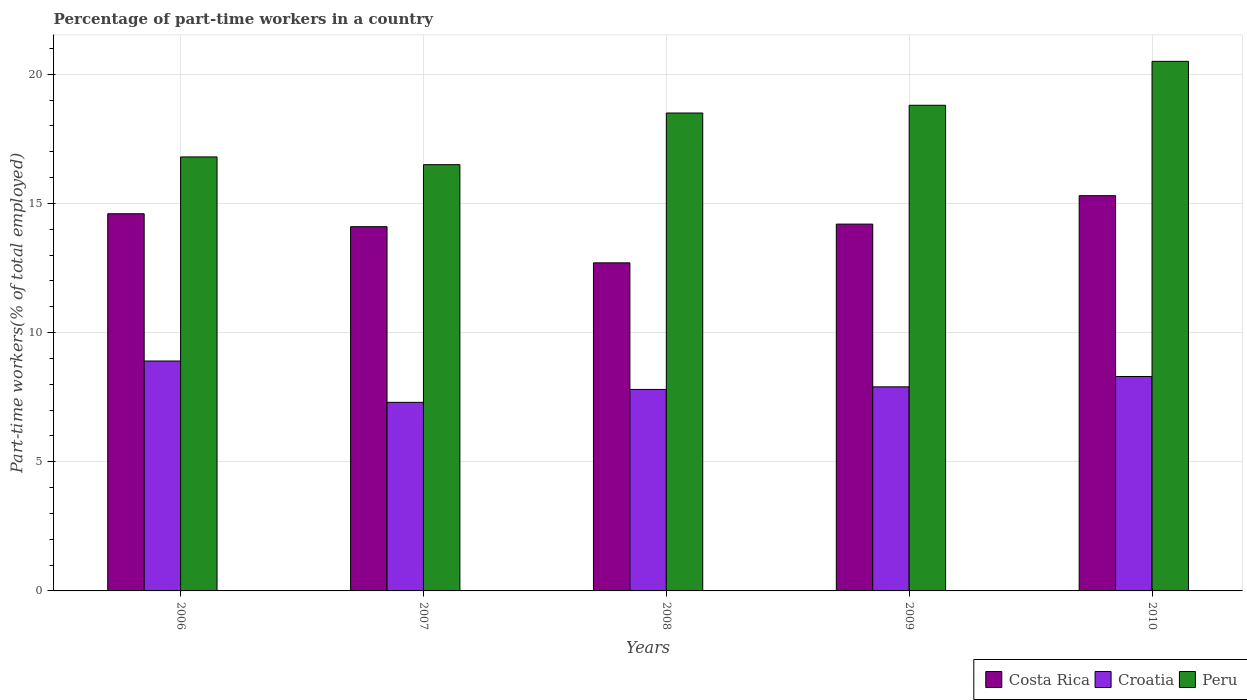How many different coloured bars are there?
Make the answer very short. 3. Are the number of bars per tick equal to the number of legend labels?
Provide a succinct answer. Yes. What is the percentage of part-time workers in Croatia in 2007?
Keep it short and to the point. 7.3. Across all years, what is the maximum percentage of part-time workers in Peru?
Keep it short and to the point. 20.5. Across all years, what is the minimum percentage of part-time workers in Peru?
Keep it short and to the point. 16.5. In which year was the percentage of part-time workers in Peru maximum?
Your answer should be very brief. 2010. In which year was the percentage of part-time workers in Croatia minimum?
Your response must be concise. 2007. What is the total percentage of part-time workers in Costa Rica in the graph?
Your answer should be compact. 70.9. What is the difference between the percentage of part-time workers in Costa Rica in 2008 and that in 2010?
Offer a very short reply. -2.6. What is the difference between the percentage of part-time workers in Costa Rica in 2010 and the percentage of part-time workers in Croatia in 2006?
Offer a terse response. 6.4. What is the average percentage of part-time workers in Croatia per year?
Your response must be concise. 8.04. In the year 2008, what is the difference between the percentage of part-time workers in Croatia and percentage of part-time workers in Costa Rica?
Your answer should be very brief. -4.9. In how many years, is the percentage of part-time workers in Croatia greater than 8 %?
Provide a short and direct response. 2. What is the ratio of the percentage of part-time workers in Croatia in 2007 to that in 2009?
Offer a very short reply. 0.92. Is the difference between the percentage of part-time workers in Croatia in 2007 and 2009 greater than the difference between the percentage of part-time workers in Costa Rica in 2007 and 2009?
Your answer should be very brief. No. What is the difference between the highest and the second highest percentage of part-time workers in Croatia?
Ensure brevity in your answer.  0.6. What is the difference between the highest and the lowest percentage of part-time workers in Costa Rica?
Make the answer very short. 2.6. What does the 3rd bar from the left in 2008 represents?
Ensure brevity in your answer.  Peru. What does the 1st bar from the right in 2006 represents?
Provide a short and direct response. Peru. Is it the case that in every year, the sum of the percentage of part-time workers in Costa Rica and percentage of part-time workers in Croatia is greater than the percentage of part-time workers in Peru?
Provide a succinct answer. Yes. What is the difference between two consecutive major ticks on the Y-axis?
Make the answer very short. 5. Does the graph contain any zero values?
Your answer should be compact. No. How many legend labels are there?
Give a very brief answer. 3. How are the legend labels stacked?
Ensure brevity in your answer.  Horizontal. What is the title of the graph?
Your answer should be compact. Percentage of part-time workers in a country. What is the label or title of the X-axis?
Your response must be concise. Years. What is the label or title of the Y-axis?
Offer a very short reply. Part-time workers(% of total employed). What is the Part-time workers(% of total employed) of Costa Rica in 2006?
Offer a terse response. 14.6. What is the Part-time workers(% of total employed) in Croatia in 2006?
Your answer should be very brief. 8.9. What is the Part-time workers(% of total employed) in Peru in 2006?
Your response must be concise. 16.8. What is the Part-time workers(% of total employed) in Costa Rica in 2007?
Your answer should be very brief. 14.1. What is the Part-time workers(% of total employed) of Croatia in 2007?
Keep it short and to the point. 7.3. What is the Part-time workers(% of total employed) in Costa Rica in 2008?
Offer a very short reply. 12.7. What is the Part-time workers(% of total employed) in Croatia in 2008?
Offer a very short reply. 7.8. What is the Part-time workers(% of total employed) in Costa Rica in 2009?
Your response must be concise. 14.2. What is the Part-time workers(% of total employed) in Croatia in 2009?
Offer a very short reply. 7.9. What is the Part-time workers(% of total employed) in Peru in 2009?
Make the answer very short. 18.8. What is the Part-time workers(% of total employed) of Costa Rica in 2010?
Your response must be concise. 15.3. What is the Part-time workers(% of total employed) of Croatia in 2010?
Your answer should be very brief. 8.3. Across all years, what is the maximum Part-time workers(% of total employed) in Costa Rica?
Make the answer very short. 15.3. Across all years, what is the maximum Part-time workers(% of total employed) of Croatia?
Make the answer very short. 8.9. Across all years, what is the maximum Part-time workers(% of total employed) of Peru?
Give a very brief answer. 20.5. Across all years, what is the minimum Part-time workers(% of total employed) in Costa Rica?
Ensure brevity in your answer.  12.7. Across all years, what is the minimum Part-time workers(% of total employed) in Croatia?
Give a very brief answer. 7.3. What is the total Part-time workers(% of total employed) of Costa Rica in the graph?
Keep it short and to the point. 70.9. What is the total Part-time workers(% of total employed) of Croatia in the graph?
Make the answer very short. 40.2. What is the total Part-time workers(% of total employed) in Peru in the graph?
Keep it short and to the point. 91.1. What is the difference between the Part-time workers(% of total employed) of Croatia in 2006 and that in 2007?
Your answer should be compact. 1.6. What is the difference between the Part-time workers(% of total employed) of Peru in 2006 and that in 2007?
Your answer should be compact. 0.3. What is the difference between the Part-time workers(% of total employed) in Peru in 2006 and that in 2008?
Your answer should be compact. -1.7. What is the difference between the Part-time workers(% of total employed) in Peru in 2006 and that in 2009?
Your answer should be very brief. -2. What is the difference between the Part-time workers(% of total employed) in Costa Rica in 2006 and that in 2010?
Make the answer very short. -0.7. What is the difference between the Part-time workers(% of total employed) of Croatia in 2006 and that in 2010?
Keep it short and to the point. 0.6. What is the difference between the Part-time workers(% of total employed) of Costa Rica in 2007 and that in 2008?
Your response must be concise. 1.4. What is the difference between the Part-time workers(% of total employed) of Croatia in 2007 and that in 2008?
Your response must be concise. -0.5. What is the difference between the Part-time workers(% of total employed) of Costa Rica in 2007 and that in 2009?
Your answer should be very brief. -0.1. What is the difference between the Part-time workers(% of total employed) in Croatia in 2007 and that in 2010?
Your answer should be compact. -1. What is the difference between the Part-time workers(% of total employed) in Costa Rica in 2008 and that in 2009?
Your answer should be compact. -1.5. What is the difference between the Part-time workers(% of total employed) in Croatia in 2008 and that in 2009?
Provide a succinct answer. -0.1. What is the difference between the Part-time workers(% of total employed) in Peru in 2008 and that in 2010?
Ensure brevity in your answer.  -2. What is the difference between the Part-time workers(% of total employed) of Croatia in 2006 and the Part-time workers(% of total employed) of Peru in 2007?
Offer a terse response. -7.6. What is the difference between the Part-time workers(% of total employed) in Costa Rica in 2006 and the Part-time workers(% of total employed) in Croatia in 2008?
Ensure brevity in your answer.  6.8. What is the difference between the Part-time workers(% of total employed) in Costa Rica in 2006 and the Part-time workers(% of total employed) in Peru in 2008?
Offer a terse response. -3.9. What is the difference between the Part-time workers(% of total employed) in Croatia in 2006 and the Part-time workers(% of total employed) in Peru in 2008?
Your response must be concise. -9.6. What is the difference between the Part-time workers(% of total employed) in Croatia in 2006 and the Part-time workers(% of total employed) in Peru in 2009?
Your answer should be very brief. -9.9. What is the difference between the Part-time workers(% of total employed) of Costa Rica in 2006 and the Part-time workers(% of total employed) of Peru in 2010?
Your answer should be very brief. -5.9. What is the difference between the Part-time workers(% of total employed) of Costa Rica in 2007 and the Part-time workers(% of total employed) of Croatia in 2008?
Keep it short and to the point. 6.3. What is the difference between the Part-time workers(% of total employed) of Costa Rica in 2007 and the Part-time workers(% of total employed) of Peru in 2008?
Offer a very short reply. -4.4. What is the difference between the Part-time workers(% of total employed) of Costa Rica in 2007 and the Part-time workers(% of total employed) of Croatia in 2009?
Your answer should be very brief. 6.2. What is the difference between the Part-time workers(% of total employed) of Costa Rica in 2007 and the Part-time workers(% of total employed) of Peru in 2009?
Ensure brevity in your answer.  -4.7. What is the difference between the Part-time workers(% of total employed) in Costa Rica in 2007 and the Part-time workers(% of total employed) in Croatia in 2010?
Ensure brevity in your answer.  5.8. What is the difference between the Part-time workers(% of total employed) in Croatia in 2007 and the Part-time workers(% of total employed) in Peru in 2010?
Offer a very short reply. -13.2. What is the difference between the Part-time workers(% of total employed) in Costa Rica in 2008 and the Part-time workers(% of total employed) in Peru in 2009?
Keep it short and to the point. -6.1. What is the difference between the Part-time workers(% of total employed) in Croatia in 2008 and the Part-time workers(% of total employed) in Peru in 2009?
Offer a terse response. -11. What is the difference between the Part-time workers(% of total employed) in Croatia in 2008 and the Part-time workers(% of total employed) in Peru in 2010?
Provide a short and direct response. -12.7. What is the average Part-time workers(% of total employed) in Costa Rica per year?
Provide a succinct answer. 14.18. What is the average Part-time workers(% of total employed) in Croatia per year?
Your answer should be very brief. 8.04. What is the average Part-time workers(% of total employed) of Peru per year?
Give a very brief answer. 18.22. In the year 2006, what is the difference between the Part-time workers(% of total employed) in Costa Rica and Part-time workers(% of total employed) in Peru?
Give a very brief answer. -2.2. In the year 2006, what is the difference between the Part-time workers(% of total employed) of Croatia and Part-time workers(% of total employed) of Peru?
Your answer should be compact. -7.9. In the year 2007, what is the difference between the Part-time workers(% of total employed) of Costa Rica and Part-time workers(% of total employed) of Croatia?
Your response must be concise. 6.8. In the year 2007, what is the difference between the Part-time workers(% of total employed) of Croatia and Part-time workers(% of total employed) of Peru?
Offer a terse response. -9.2. In the year 2008, what is the difference between the Part-time workers(% of total employed) of Costa Rica and Part-time workers(% of total employed) of Croatia?
Give a very brief answer. 4.9. In the year 2008, what is the difference between the Part-time workers(% of total employed) of Croatia and Part-time workers(% of total employed) of Peru?
Your answer should be very brief. -10.7. In the year 2009, what is the difference between the Part-time workers(% of total employed) in Costa Rica and Part-time workers(% of total employed) in Peru?
Your answer should be very brief. -4.6. In the year 2010, what is the difference between the Part-time workers(% of total employed) of Costa Rica and Part-time workers(% of total employed) of Peru?
Your answer should be very brief. -5.2. In the year 2010, what is the difference between the Part-time workers(% of total employed) of Croatia and Part-time workers(% of total employed) of Peru?
Your response must be concise. -12.2. What is the ratio of the Part-time workers(% of total employed) of Costa Rica in 2006 to that in 2007?
Keep it short and to the point. 1.04. What is the ratio of the Part-time workers(% of total employed) of Croatia in 2006 to that in 2007?
Make the answer very short. 1.22. What is the ratio of the Part-time workers(% of total employed) in Peru in 2006 to that in 2007?
Make the answer very short. 1.02. What is the ratio of the Part-time workers(% of total employed) in Costa Rica in 2006 to that in 2008?
Your answer should be compact. 1.15. What is the ratio of the Part-time workers(% of total employed) in Croatia in 2006 to that in 2008?
Offer a terse response. 1.14. What is the ratio of the Part-time workers(% of total employed) of Peru in 2006 to that in 2008?
Offer a terse response. 0.91. What is the ratio of the Part-time workers(% of total employed) in Costa Rica in 2006 to that in 2009?
Provide a short and direct response. 1.03. What is the ratio of the Part-time workers(% of total employed) of Croatia in 2006 to that in 2009?
Your response must be concise. 1.13. What is the ratio of the Part-time workers(% of total employed) of Peru in 2006 to that in 2009?
Make the answer very short. 0.89. What is the ratio of the Part-time workers(% of total employed) in Costa Rica in 2006 to that in 2010?
Make the answer very short. 0.95. What is the ratio of the Part-time workers(% of total employed) in Croatia in 2006 to that in 2010?
Your answer should be compact. 1.07. What is the ratio of the Part-time workers(% of total employed) in Peru in 2006 to that in 2010?
Ensure brevity in your answer.  0.82. What is the ratio of the Part-time workers(% of total employed) of Costa Rica in 2007 to that in 2008?
Provide a short and direct response. 1.11. What is the ratio of the Part-time workers(% of total employed) in Croatia in 2007 to that in 2008?
Provide a short and direct response. 0.94. What is the ratio of the Part-time workers(% of total employed) in Peru in 2007 to that in 2008?
Ensure brevity in your answer.  0.89. What is the ratio of the Part-time workers(% of total employed) of Costa Rica in 2007 to that in 2009?
Provide a succinct answer. 0.99. What is the ratio of the Part-time workers(% of total employed) in Croatia in 2007 to that in 2009?
Provide a short and direct response. 0.92. What is the ratio of the Part-time workers(% of total employed) of Peru in 2007 to that in 2009?
Give a very brief answer. 0.88. What is the ratio of the Part-time workers(% of total employed) in Costa Rica in 2007 to that in 2010?
Give a very brief answer. 0.92. What is the ratio of the Part-time workers(% of total employed) of Croatia in 2007 to that in 2010?
Offer a terse response. 0.88. What is the ratio of the Part-time workers(% of total employed) in Peru in 2007 to that in 2010?
Make the answer very short. 0.8. What is the ratio of the Part-time workers(% of total employed) in Costa Rica in 2008 to that in 2009?
Ensure brevity in your answer.  0.89. What is the ratio of the Part-time workers(% of total employed) of Croatia in 2008 to that in 2009?
Make the answer very short. 0.99. What is the ratio of the Part-time workers(% of total employed) in Peru in 2008 to that in 2009?
Provide a succinct answer. 0.98. What is the ratio of the Part-time workers(% of total employed) in Costa Rica in 2008 to that in 2010?
Ensure brevity in your answer.  0.83. What is the ratio of the Part-time workers(% of total employed) of Croatia in 2008 to that in 2010?
Make the answer very short. 0.94. What is the ratio of the Part-time workers(% of total employed) in Peru in 2008 to that in 2010?
Offer a terse response. 0.9. What is the ratio of the Part-time workers(% of total employed) in Costa Rica in 2009 to that in 2010?
Provide a short and direct response. 0.93. What is the ratio of the Part-time workers(% of total employed) in Croatia in 2009 to that in 2010?
Provide a short and direct response. 0.95. What is the ratio of the Part-time workers(% of total employed) of Peru in 2009 to that in 2010?
Provide a short and direct response. 0.92. What is the difference between the highest and the second highest Part-time workers(% of total employed) of Costa Rica?
Provide a succinct answer. 0.7. What is the difference between the highest and the second highest Part-time workers(% of total employed) of Croatia?
Your answer should be compact. 0.6. What is the difference between the highest and the second highest Part-time workers(% of total employed) of Peru?
Offer a very short reply. 1.7. What is the difference between the highest and the lowest Part-time workers(% of total employed) in Peru?
Offer a very short reply. 4. 